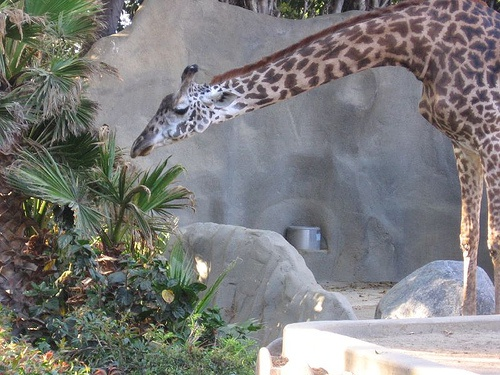Describe the objects in this image and their specific colors. I can see a giraffe in darkgreen, gray, darkgray, and black tones in this image. 